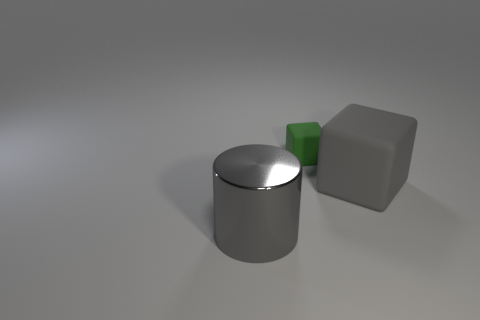Add 2 large purple rubber blocks. How many objects exist? 5 Subtract all cylinders. How many objects are left? 2 Subtract 1 gray blocks. How many objects are left? 2 Subtract all cyan cubes. Subtract all tiny green matte blocks. How many objects are left? 2 Add 2 tiny green cubes. How many tiny green cubes are left? 3 Add 3 big cylinders. How many big cylinders exist? 4 